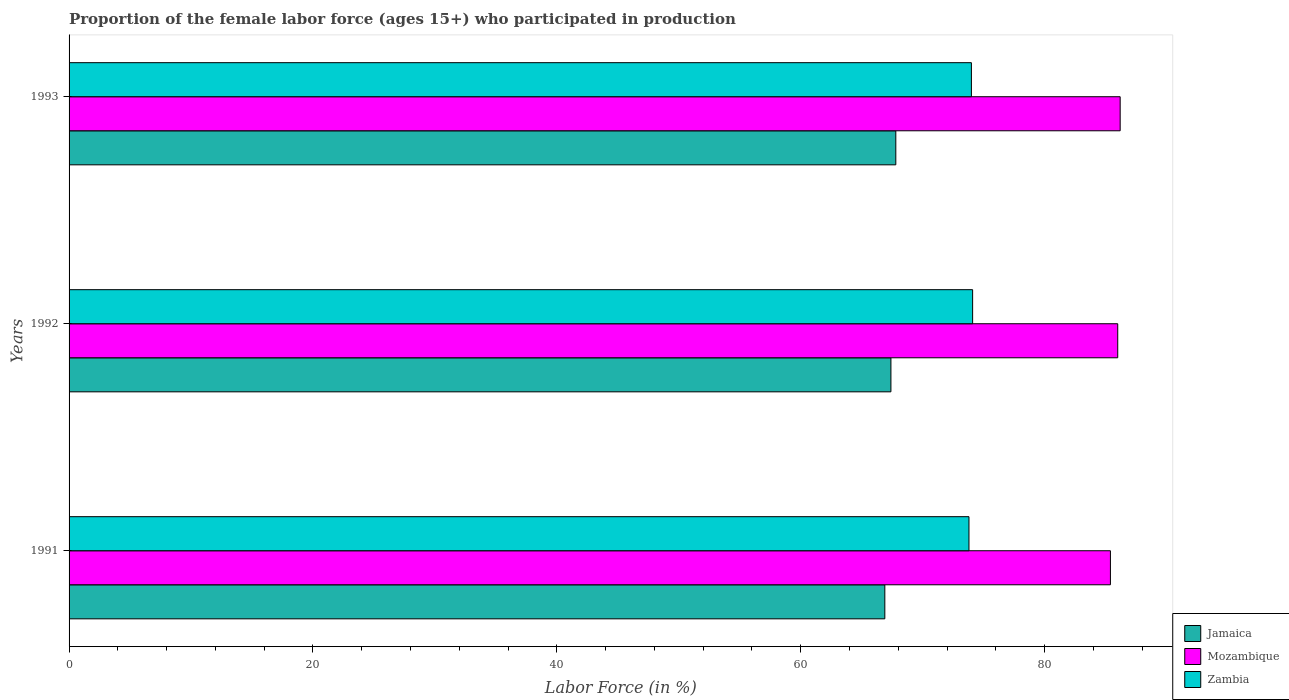How many bars are there on the 1st tick from the top?
Keep it short and to the point. 3. How many bars are there on the 1st tick from the bottom?
Provide a short and direct response. 3. What is the label of the 3rd group of bars from the top?
Provide a succinct answer. 1991. What is the proportion of the female labor force who participated in production in Mozambique in 1991?
Offer a terse response. 85.4. Across all years, what is the maximum proportion of the female labor force who participated in production in Mozambique?
Give a very brief answer. 86.2. Across all years, what is the minimum proportion of the female labor force who participated in production in Mozambique?
Your answer should be compact. 85.4. In which year was the proportion of the female labor force who participated in production in Mozambique minimum?
Ensure brevity in your answer.  1991. What is the total proportion of the female labor force who participated in production in Mozambique in the graph?
Ensure brevity in your answer.  257.6. What is the difference between the proportion of the female labor force who participated in production in Mozambique in 1991 and that in 1992?
Provide a succinct answer. -0.6. What is the difference between the proportion of the female labor force who participated in production in Mozambique in 1992 and the proportion of the female labor force who participated in production in Jamaica in 1993?
Ensure brevity in your answer.  18.2. What is the average proportion of the female labor force who participated in production in Zambia per year?
Your answer should be very brief. 73.97. In the year 1991, what is the difference between the proportion of the female labor force who participated in production in Mozambique and proportion of the female labor force who participated in production in Jamaica?
Provide a succinct answer. 18.5. What is the ratio of the proportion of the female labor force who participated in production in Mozambique in 1991 to that in 1992?
Your answer should be very brief. 0.99. Is the difference between the proportion of the female labor force who participated in production in Mozambique in 1991 and 1993 greater than the difference between the proportion of the female labor force who participated in production in Jamaica in 1991 and 1993?
Ensure brevity in your answer.  Yes. What is the difference between the highest and the second highest proportion of the female labor force who participated in production in Mozambique?
Offer a very short reply. 0.2. What is the difference between the highest and the lowest proportion of the female labor force who participated in production in Zambia?
Offer a terse response. 0.3. In how many years, is the proportion of the female labor force who participated in production in Jamaica greater than the average proportion of the female labor force who participated in production in Jamaica taken over all years?
Keep it short and to the point. 2. Is the sum of the proportion of the female labor force who participated in production in Jamaica in 1991 and 1993 greater than the maximum proportion of the female labor force who participated in production in Zambia across all years?
Offer a terse response. Yes. What does the 2nd bar from the top in 1992 represents?
Provide a succinct answer. Mozambique. What does the 1st bar from the bottom in 1991 represents?
Your response must be concise. Jamaica. Are all the bars in the graph horizontal?
Your response must be concise. Yes. How many years are there in the graph?
Offer a terse response. 3. What is the difference between two consecutive major ticks on the X-axis?
Give a very brief answer. 20. Does the graph contain any zero values?
Offer a very short reply. No. Where does the legend appear in the graph?
Make the answer very short. Bottom right. What is the title of the graph?
Offer a terse response. Proportion of the female labor force (ages 15+) who participated in production. What is the label or title of the X-axis?
Offer a terse response. Labor Force (in %). What is the Labor Force (in %) in Jamaica in 1991?
Provide a succinct answer. 66.9. What is the Labor Force (in %) of Mozambique in 1991?
Your response must be concise. 85.4. What is the Labor Force (in %) of Zambia in 1991?
Provide a succinct answer. 73.8. What is the Labor Force (in %) of Jamaica in 1992?
Offer a terse response. 67.4. What is the Labor Force (in %) in Mozambique in 1992?
Offer a terse response. 86. What is the Labor Force (in %) of Zambia in 1992?
Keep it short and to the point. 74.1. What is the Labor Force (in %) of Jamaica in 1993?
Give a very brief answer. 67.8. What is the Labor Force (in %) in Mozambique in 1993?
Offer a very short reply. 86.2. What is the Labor Force (in %) of Zambia in 1993?
Your answer should be very brief. 74. Across all years, what is the maximum Labor Force (in %) of Jamaica?
Ensure brevity in your answer.  67.8. Across all years, what is the maximum Labor Force (in %) of Mozambique?
Make the answer very short. 86.2. Across all years, what is the maximum Labor Force (in %) in Zambia?
Ensure brevity in your answer.  74.1. Across all years, what is the minimum Labor Force (in %) in Jamaica?
Offer a very short reply. 66.9. Across all years, what is the minimum Labor Force (in %) of Mozambique?
Give a very brief answer. 85.4. Across all years, what is the minimum Labor Force (in %) of Zambia?
Ensure brevity in your answer.  73.8. What is the total Labor Force (in %) in Jamaica in the graph?
Keep it short and to the point. 202.1. What is the total Labor Force (in %) of Mozambique in the graph?
Make the answer very short. 257.6. What is the total Labor Force (in %) of Zambia in the graph?
Keep it short and to the point. 221.9. What is the difference between the Labor Force (in %) of Zambia in 1991 and that in 1992?
Provide a succinct answer. -0.3. What is the difference between the Labor Force (in %) in Jamaica in 1992 and that in 1993?
Provide a succinct answer. -0.4. What is the difference between the Labor Force (in %) of Mozambique in 1992 and that in 1993?
Keep it short and to the point. -0.2. What is the difference between the Labor Force (in %) in Jamaica in 1991 and the Labor Force (in %) in Mozambique in 1992?
Provide a succinct answer. -19.1. What is the difference between the Labor Force (in %) of Jamaica in 1991 and the Labor Force (in %) of Mozambique in 1993?
Provide a short and direct response. -19.3. What is the difference between the Labor Force (in %) in Jamaica in 1992 and the Labor Force (in %) in Mozambique in 1993?
Make the answer very short. -18.8. What is the difference between the Labor Force (in %) of Jamaica in 1992 and the Labor Force (in %) of Zambia in 1993?
Provide a short and direct response. -6.6. What is the average Labor Force (in %) of Jamaica per year?
Make the answer very short. 67.37. What is the average Labor Force (in %) in Mozambique per year?
Your response must be concise. 85.87. What is the average Labor Force (in %) of Zambia per year?
Offer a terse response. 73.97. In the year 1991, what is the difference between the Labor Force (in %) of Jamaica and Labor Force (in %) of Mozambique?
Keep it short and to the point. -18.5. In the year 1991, what is the difference between the Labor Force (in %) of Jamaica and Labor Force (in %) of Zambia?
Ensure brevity in your answer.  -6.9. In the year 1991, what is the difference between the Labor Force (in %) in Mozambique and Labor Force (in %) in Zambia?
Your answer should be very brief. 11.6. In the year 1992, what is the difference between the Labor Force (in %) of Jamaica and Labor Force (in %) of Mozambique?
Provide a short and direct response. -18.6. In the year 1992, what is the difference between the Labor Force (in %) of Mozambique and Labor Force (in %) of Zambia?
Provide a succinct answer. 11.9. In the year 1993, what is the difference between the Labor Force (in %) in Jamaica and Labor Force (in %) in Mozambique?
Make the answer very short. -18.4. What is the ratio of the Labor Force (in %) in Jamaica in 1991 to that in 1992?
Offer a terse response. 0.99. What is the ratio of the Labor Force (in %) of Zambia in 1991 to that in 1992?
Ensure brevity in your answer.  1. What is the ratio of the Labor Force (in %) in Jamaica in 1991 to that in 1993?
Ensure brevity in your answer.  0.99. What is the ratio of the Labor Force (in %) in Mozambique in 1991 to that in 1993?
Your answer should be very brief. 0.99. What is the ratio of the Labor Force (in %) of Jamaica in 1992 to that in 1993?
Give a very brief answer. 0.99. What is the difference between the highest and the second highest Labor Force (in %) of Jamaica?
Offer a terse response. 0.4. 